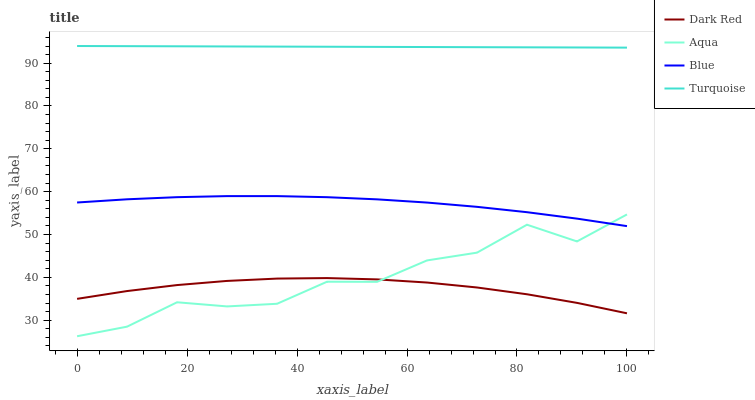Does Turquoise have the minimum area under the curve?
Answer yes or no. No. Does Dark Red have the maximum area under the curve?
Answer yes or no. No. Is Dark Red the smoothest?
Answer yes or no. No. Is Dark Red the roughest?
Answer yes or no. No. Does Dark Red have the lowest value?
Answer yes or no. No. Does Dark Red have the highest value?
Answer yes or no. No. Is Aqua less than Turquoise?
Answer yes or no. Yes. Is Blue greater than Dark Red?
Answer yes or no. Yes. Does Aqua intersect Turquoise?
Answer yes or no. No. 